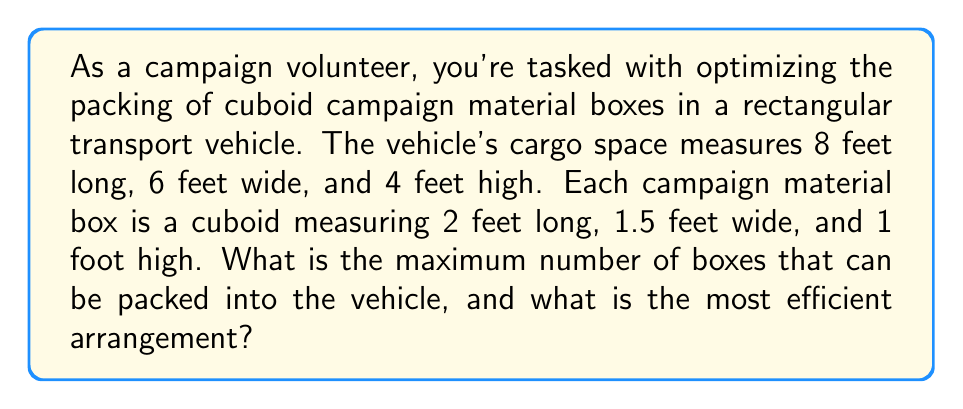Help me with this question. To solve this problem, we need to determine the most efficient packing arrangement that maximizes the number of boxes in the given space. Let's approach this step-by-step:

1. Calculate the volume of the cargo space:
   $$V_{cargo} = 8 \text{ ft} \times 6 \text{ ft} \times 4 \text{ ft} = 192 \text{ ft}^3$$

2. Calculate the volume of each box:
   $$V_{box} = 2 \text{ ft} \times 1.5 \text{ ft} \times 1 \text{ ft} = 3 \text{ ft}^3$$

3. Theoretically, if we could perfectly pack the space, the maximum number of boxes would be:
   $$\text{Theoretical max} = \frac{V_{cargo}}{V_{box}} = \frac{192}{3} = 64 \text{ boxes}$$

4. However, we need to consider the actual dimensions. Let's look at possible arrangements:

   a. Lengthwise: 8 ft ÷ 2 ft = 4 boxes
   b. Widthwise: 6 ft ÷ 1.5 ft = 4 boxes
   c. Height-wise: 4 ft ÷ 1 ft = 4 boxes

5. The most efficient arrangement would be:
   - 4 boxes along the length
   - 4 boxes along the width
   - 4 boxes stacked vertically

6. Total number of boxes:
   $$4 \times 4 \times 4 = 64 \text{ boxes}$$

This arrangement perfectly fits the cargo space without any wasted space.

[asy]
import three;

size(200);
currentprojection=perspective(6,3,2);

// Cargo space
draw(box((0,0,0),(8,6,4)),rgb(0.8,0.8,0.8));

// Boxes
for(int x=0; x<4; ++x)
  for(int y=0; y<4; ++y)
    for(int z=0; z<4; ++z)
      draw(shift(2x,1.5y,z)*box((0,0,0),(2,1.5,1)),rgb(1,0.7,0.7));

label("8 ft",point(8,3,0),S);
label("6 ft",point(4,6,0),E);
label("4 ft",point(0,0,4),N);
[/asy]
Answer: The maximum number of boxes that can be packed is 64, arranged in a 4x4x4 configuration (4 boxes long, 4 boxes wide, 4 boxes high). 